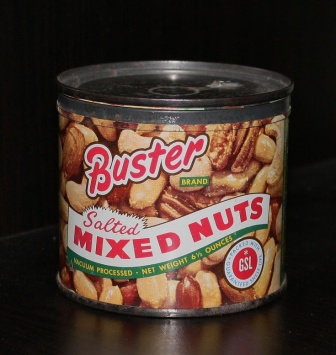What do you see happening in this image? In the image, there's a prominently displayed cylindrical can of Buster brand salted mixed nuts placed on a dark wooden surface. The can, sealed with a black lid, features a vibrant label with a mix of red, white, and yellow colors designed to attract attention. The label reads "Buster Brand Salted Mixed Nuts" in bold red and white text. Additionally, it showcases an enticing image of a variety of nuts, including pecans, almonds, and cashews, hinting at the delicious assortment inside. The can's positioning on the wooden surface, combined with its colorful label, makes it the central focus of the image. 